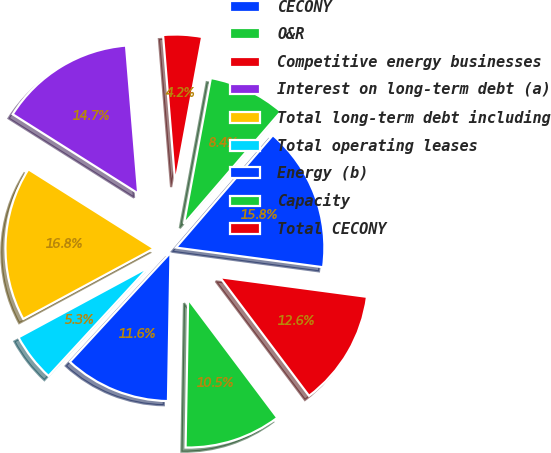Convert chart. <chart><loc_0><loc_0><loc_500><loc_500><pie_chart><fcel>CECONY<fcel>O&R<fcel>Competitive energy businesses<fcel>Interest on long-term debt (a)<fcel>Total long-term debt including<fcel>Total operating leases<fcel>Energy (b)<fcel>Capacity<fcel>Total CECONY<nl><fcel>15.79%<fcel>8.42%<fcel>4.21%<fcel>14.73%<fcel>16.84%<fcel>5.27%<fcel>11.58%<fcel>10.53%<fcel>12.63%<nl></chart> 